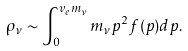Convert formula to latex. <formula><loc_0><loc_0><loc_500><loc_500>\rho _ { \nu } \sim \int _ { 0 } ^ { v _ { e } m _ { \nu } } m _ { \nu } p ^ { 2 } f ( p ) d p .</formula> 